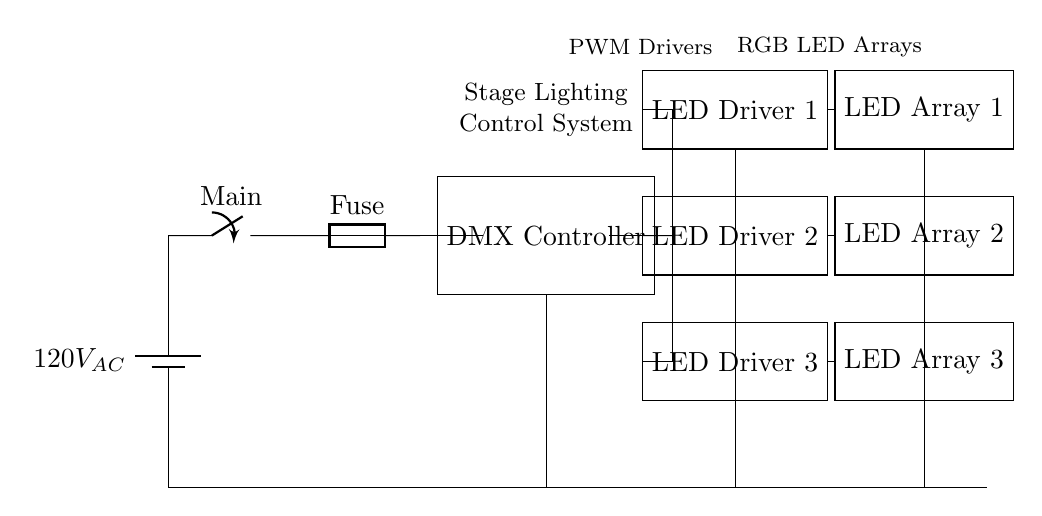What is the voltage supply in this circuit? The voltage supply comes from a source labeled as a battery, which is marked with a value of 120 volts. This indicates the potential difference available to power the circuit.
Answer: 120V What are the main components in this circuit? The major components visible in the circuit diagram are the main switch, fuse, DMX controller, LED drivers, and LED arrays. Each serves a distinct function in controlling the LED lighting setup.
Answer: Main switch, fuse, DMX controller, LED drivers, LED arrays How many LED drivers are present in the circuit? By counting the rectangular components designated as LED drivers, there are three distinct LED driver units listed in the circuit.
Answer: Three What role does the DMX controller play in this setup? The DMX controller is crucial for receiving input signals that dictate the behavior of the connected lighting components, like LED drivers, thereby enabling control of lighting effects during performances.
Answer: Lighting control Why does the diagram include a fuse? The fuse is included as a protective device to prevent excessive current flow, which could cause damage to the circuit or create a safety hazard. It ensures the circuit remains intact during high power operations.
Answer: Protection against overcurrent Which component connects directly to the battery first? The first component connected directly to the battery in this circuit is the main switch, which allows control of the power flow from the battery to the rest of the circuit.
Answer: Main switch How do the LED drivers connect to the LED arrays? Each LED driver is shown to connect directly to its corresponding LED array, allowing the converted power to drive the LEDs, enabling them to light up effectively as per the signals processed from the DMX controller.
Answer: Direct connections 